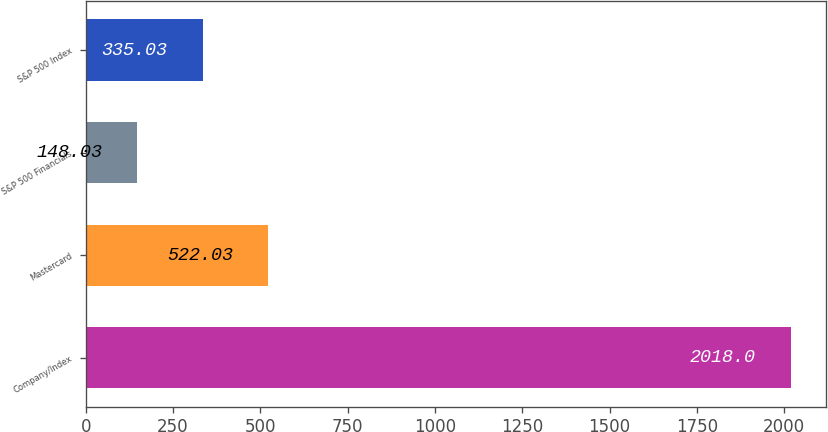Convert chart to OTSL. <chart><loc_0><loc_0><loc_500><loc_500><bar_chart><fcel>Company/Index<fcel>Mastercard<fcel>S&P 500 Financials<fcel>S&P 500 Index<nl><fcel>2018<fcel>522.03<fcel>148.03<fcel>335.03<nl></chart> 